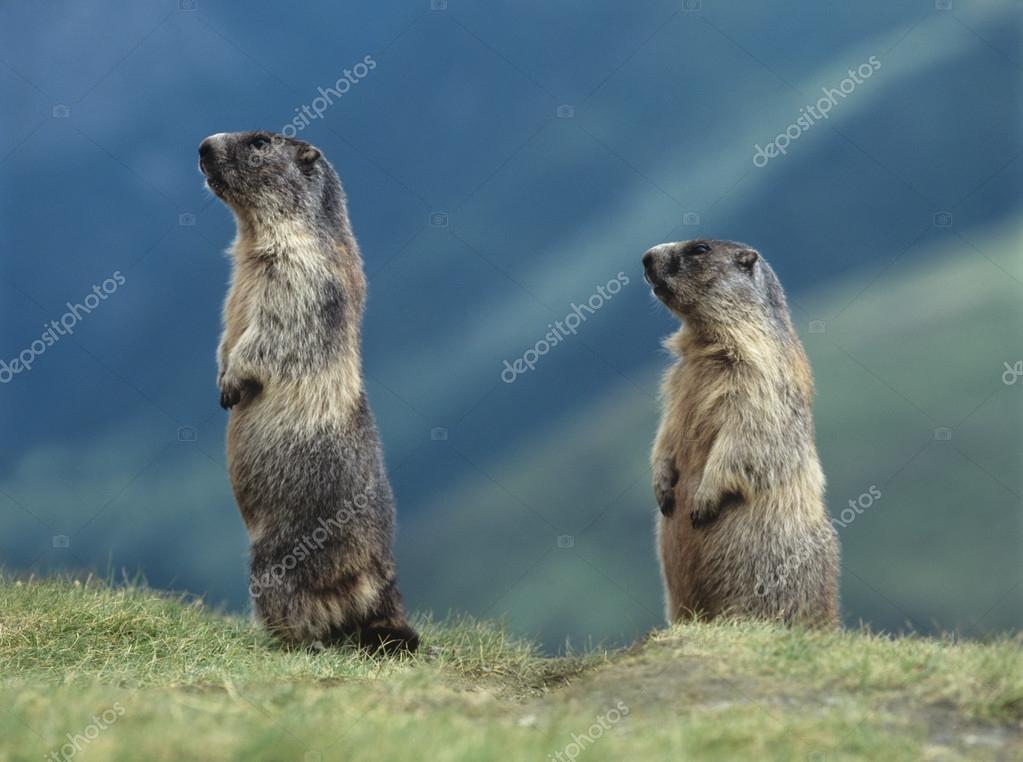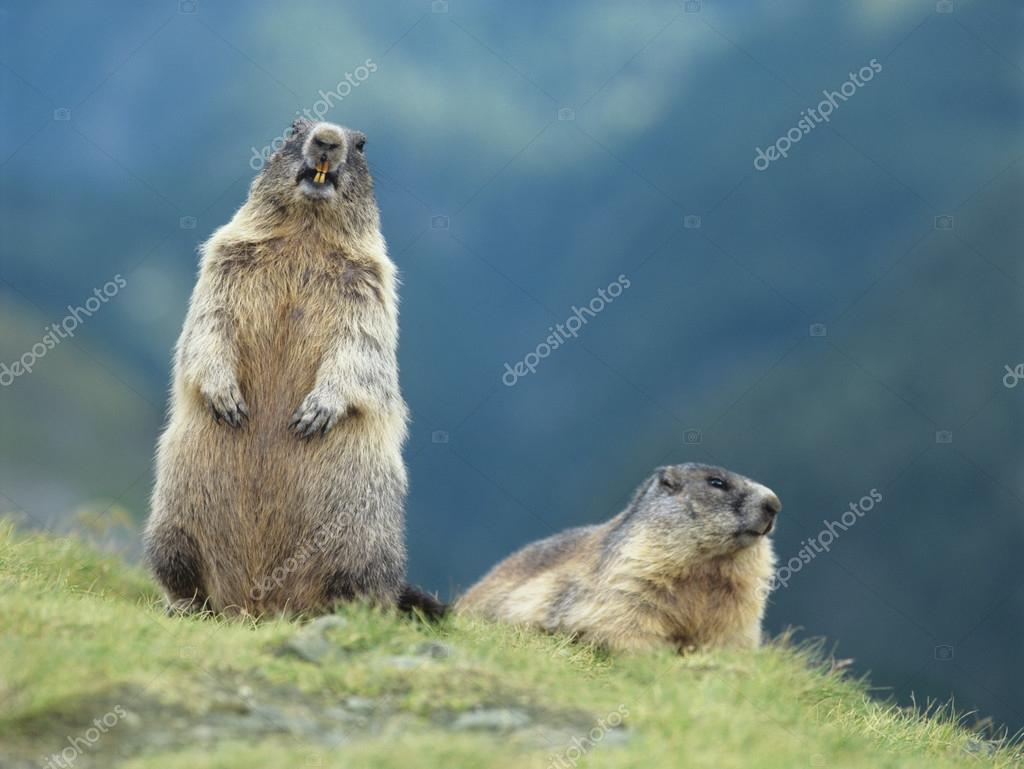The first image is the image on the left, the second image is the image on the right. Evaluate the accuracy of this statement regarding the images: "An image shows two similarly-posed upright marmots, each facing leftward.". Is it true? Answer yes or no. Yes. The first image is the image on the left, the second image is the image on the right. For the images shown, is this caption "In one of the images, there are two animals facing left." true? Answer yes or no. Yes. 